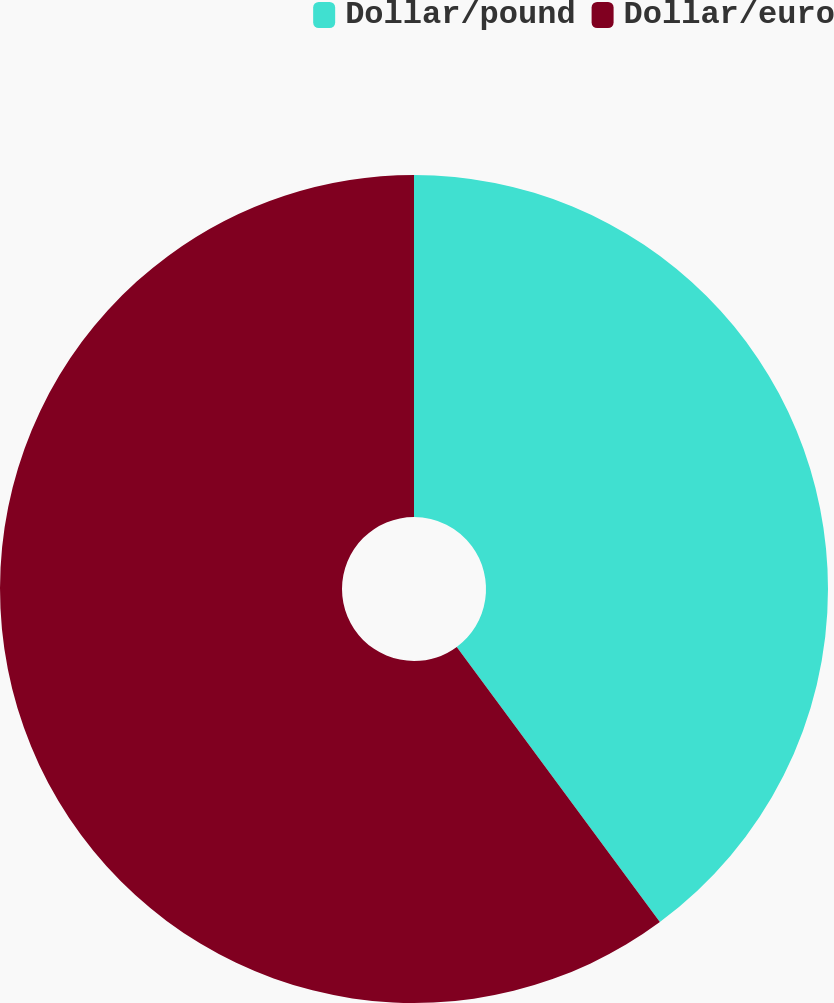Convert chart. <chart><loc_0><loc_0><loc_500><loc_500><pie_chart><fcel>Dollar/pound<fcel>Dollar/euro<nl><fcel>39.88%<fcel>60.12%<nl></chart> 